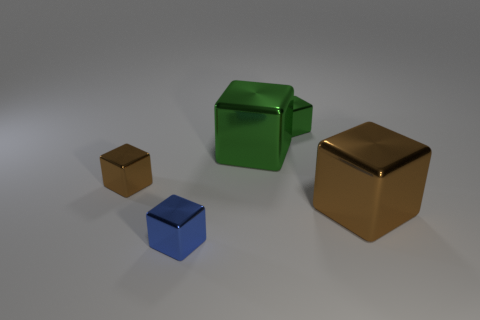Subtract all purple balls. How many brown cubes are left? 2 Subtract all tiny brown blocks. How many blocks are left? 4 Add 1 brown metallic blocks. How many objects exist? 6 Subtract 2 blocks. How many blocks are left? 3 Subtract all blue blocks. How many blocks are left? 4 Subtract all large yellow objects. Subtract all brown objects. How many objects are left? 3 Add 1 tiny brown metal objects. How many tiny brown metal objects are left? 2 Add 5 large brown objects. How many large brown objects exist? 6 Subtract 0 red blocks. How many objects are left? 5 Subtract all gray cubes. Subtract all green cylinders. How many cubes are left? 5 